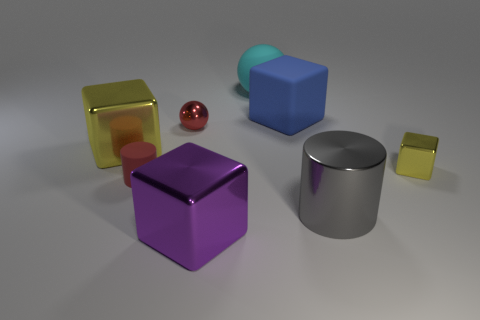Subtract all green blocks. Subtract all green cylinders. How many blocks are left? 4 Add 2 tiny yellow metal blocks. How many objects exist? 10 Subtract all spheres. How many objects are left? 6 Subtract 1 yellow cubes. How many objects are left? 7 Subtract all purple blocks. Subtract all small yellow rubber balls. How many objects are left? 7 Add 3 matte things. How many matte things are left? 6 Add 3 rubber things. How many rubber things exist? 6 